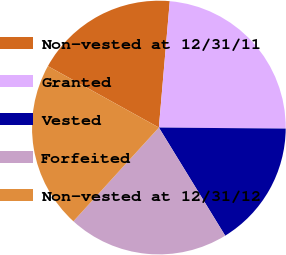Convert chart to OTSL. <chart><loc_0><loc_0><loc_500><loc_500><pie_chart><fcel>Non-vested at 12/31/11<fcel>Granted<fcel>Vested<fcel>Forfeited<fcel>Non-vested at 12/31/12<nl><fcel>18.32%<fcel>23.76%<fcel>16.11%<fcel>20.52%<fcel>21.28%<nl></chart> 